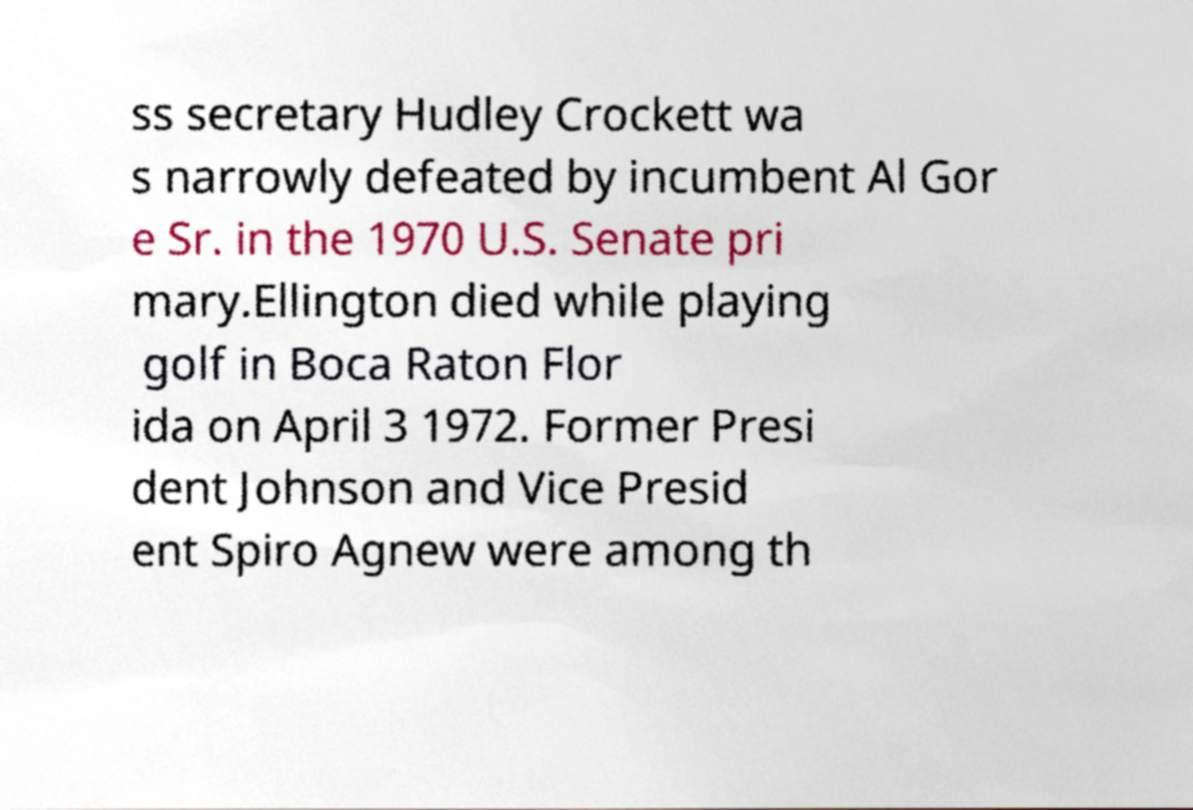Can you accurately transcribe the text from the provided image for me? ss secretary Hudley Crockett wa s narrowly defeated by incumbent Al Gor e Sr. in the 1970 U.S. Senate pri mary.Ellington died while playing golf in Boca Raton Flor ida on April 3 1972. Former Presi dent Johnson and Vice Presid ent Spiro Agnew were among th 